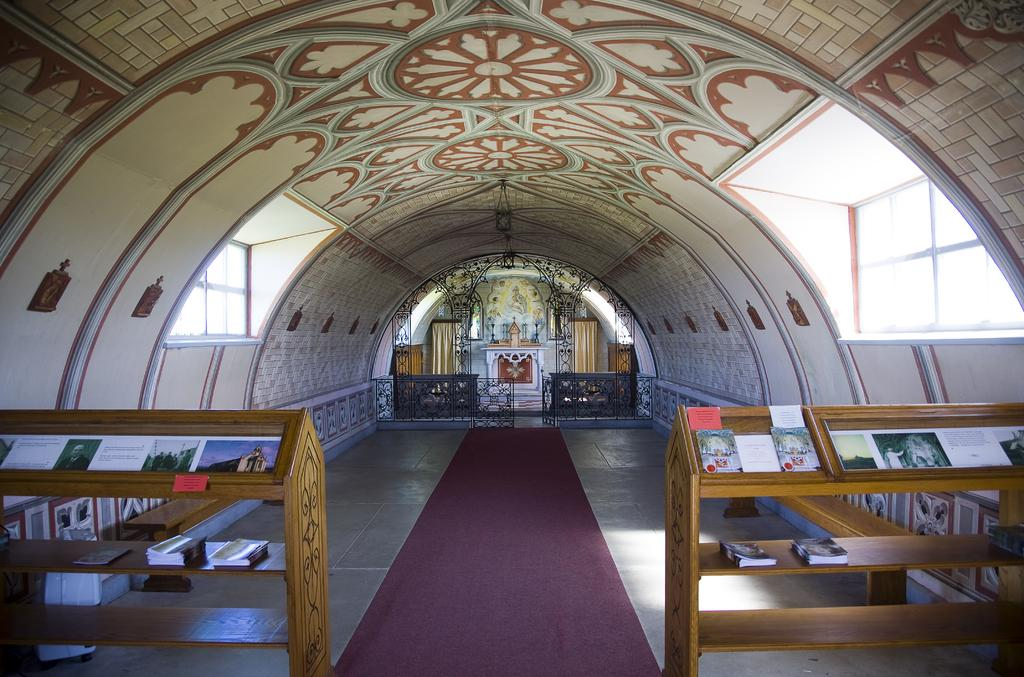What color are the racks in the image? The racks in the image are brown. What can be found on the racks? There are books on the racks. What can be seen in the background of the image? There are benches visible in the background of the image. How does the aunt control the pests in the image? There is no aunt or pests present in the image; it only features brown color racks with books and benches in the background. 